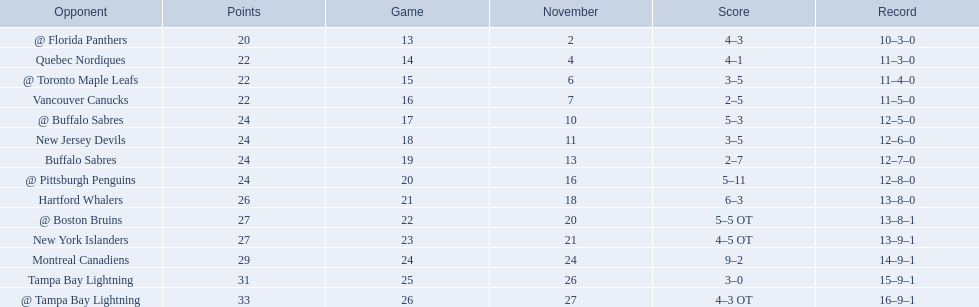What were the scores of the 1993-94 philadelphia flyers season? 4–3, 4–1, 3–5, 2–5, 5–3, 3–5, 2–7, 5–11, 6–3, 5–5 OT, 4–5 OT, 9–2, 3–0, 4–3 OT. Which of these teams had the score 4-5 ot? New York Islanders. 